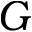<formula> <loc_0><loc_0><loc_500><loc_500>G</formula> 